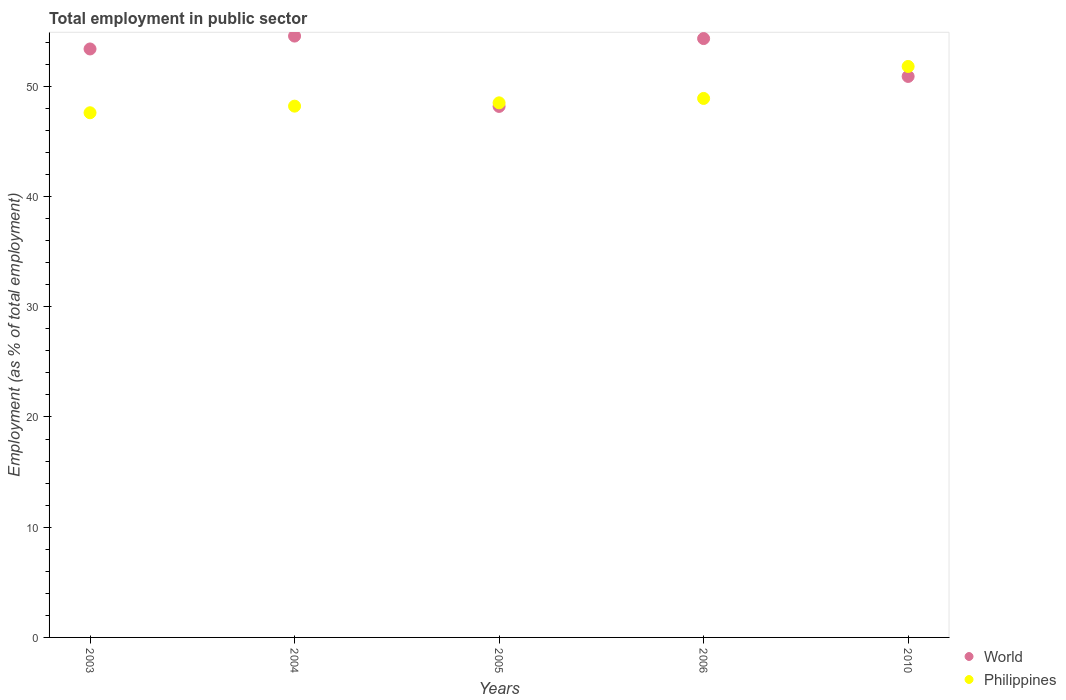Is the number of dotlines equal to the number of legend labels?
Your response must be concise. Yes. What is the employment in public sector in World in 2005?
Make the answer very short. 48.17. Across all years, what is the maximum employment in public sector in Philippines?
Offer a terse response. 51.8. Across all years, what is the minimum employment in public sector in World?
Keep it short and to the point. 48.17. In which year was the employment in public sector in World minimum?
Your answer should be compact. 2005. What is the total employment in public sector in Philippines in the graph?
Make the answer very short. 245. What is the difference between the employment in public sector in World in 2003 and that in 2010?
Provide a short and direct response. 2.49. What is the difference between the employment in public sector in Philippines in 2006 and the employment in public sector in World in 2003?
Ensure brevity in your answer.  -4.49. In the year 2006, what is the difference between the employment in public sector in Philippines and employment in public sector in World?
Keep it short and to the point. -5.43. In how many years, is the employment in public sector in World greater than 2 %?
Give a very brief answer. 5. What is the ratio of the employment in public sector in Philippines in 2005 to that in 2006?
Ensure brevity in your answer.  0.99. Is the difference between the employment in public sector in Philippines in 2004 and 2005 greater than the difference between the employment in public sector in World in 2004 and 2005?
Make the answer very short. No. What is the difference between the highest and the second highest employment in public sector in Philippines?
Your answer should be compact. 2.9. What is the difference between the highest and the lowest employment in public sector in Philippines?
Offer a terse response. 4.2. Is the sum of the employment in public sector in World in 2003 and 2006 greater than the maximum employment in public sector in Philippines across all years?
Your response must be concise. Yes. Is the employment in public sector in Philippines strictly greater than the employment in public sector in World over the years?
Keep it short and to the point. No. Is the employment in public sector in Philippines strictly less than the employment in public sector in World over the years?
Your response must be concise. No. What is the difference between two consecutive major ticks on the Y-axis?
Provide a succinct answer. 10. Are the values on the major ticks of Y-axis written in scientific E-notation?
Your answer should be compact. No. Does the graph contain any zero values?
Provide a succinct answer. No. How many legend labels are there?
Offer a terse response. 2. How are the legend labels stacked?
Keep it short and to the point. Vertical. What is the title of the graph?
Ensure brevity in your answer.  Total employment in public sector. Does "Turkmenistan" appear as one of the legend labels in the graph?
Your response must be concise. No. What is the label or title of the Y-axis?
Make the answer very short. Employment (as % of total employment). What is the Employment (as % of total employment) of World in 2003?
Give a very brief answer. 53.39. What is the Employment (as % of total employment) of Philippines in 2003?
Make the answer very short. 47.6. What is the Employment (as % of total employment) of World in 2004?
Make the answer very short. 54.56. What is the Employment (as % of total employment) in Philippines in 2004?
Give a very brief answer. 48.2. What is the Employment (as % of total employment) of World in 2005?
Your answer should be very brief. 48.17. What is the Employment (as % of total employment) of Philippines in 2005?
Provide a succinct answer. 48.5. What is the Employment (as % of total employment) of World in 2006?
Offer a terse response. 54.33. What is the Employment (as % of total employment) in Philippines in 2006?
Your response must be concise. 48.9. What is the Employment (as % of total employment) of World in 2010?
Your response must be concise. 50.9. What is the Employment (as % of total employment) in Philippines in 2010?
Provide a short and direct response. 51.8. Across all years, what is the maximum Employment (as % of total employment) in World?
Your response must be concise. 54.56. Across all years, what is the maximum Employment (as % of total employment) of Philippines?
Ensure brevity in your answer.  51.8. Across all years, what is the minimum Employment (as % of total employment) of World?
Keep it short and to the point. 48.17. Across all years, what is the minimum Employment (as % of total employment) in Philippines?
Offer a terse response. 47.6. What is the total Employment (as % of total employment) of World in the graph?
Ensure brevity in your answer.  261.35. What is the total Employment (as % of total employment) of Philippines in the graph?
Keep it short and to the point. 245. What is the difference between the Employment (as % of total employment) of World in 2003 and that in 2004?
Offer a very short reply. -1.17. What is the difference between the Employment (as % of total employment) of Philippines in 2003 and that in 2004?
Offer a terse response. -0.6. What is the difference between the Employment (as % of total employment) of World in 2003 and that in 2005?
Your answer should be very brief. 5.21. What is the difference between the Employment (as % of total employment) in Philippines in 2003 and that in 2005?
Ensure brevity in your answer.  -0.9. What is the difference between the Employment (as % of total employment) in World in 2003 and that in 2006?
Ensure brevity in your answer.  -0.94. What is the difference between the Employment (as % of total employment) of World in 2003 and that in 2010?
Offer a very short reply. 2.49. What is the difference between the Employment (as % of total employment) of Philippines in 2003 and that in 2010?
Make the answer very short. -4.2. What is the difference between the Employment (as % of total employment) in World in 2004 and that in 2005?
Give a very brief answer. 6.38. What is the difference between the Employment (as % of total employment) of Philippines in 2004 and that in 2005?
Provide a succinct answer. -0.3. What is the difference between the Employment (as % of total employment) of World in 2004 and that in 2006?
Provide a short and direct response. 0.23. What is the difference between the Employment (as % of total employment) of Philippines in 2004 and that in 2006?
Keep it short and to the point. -0.7. What is the difference between the Employment (as % of total employment) of World in 2004 and that in 2010?
Your answer should be compact. 3.66. What is the difference between the Employment (as % of total employment) in World in 2005 and that in 2006?
Offer a terse response. -6.16. What is the difference between the Employment (as % of total employment) of Philippines in 2005 and that in 2006?
Provide a succinct answer. -0.4. What is the difference between the Employment (as % of total employment) of World in 2005 and that in 2010?
Your answer should be very brief. -2.72. What is the difference between the Employment (as % of total employment) of Philippines in 2005 and that in 2010?
Provide a short and direct response. -3.3. What is the difference between the Employment (as % of total employment) of World in 2006 and that in 2010?
Your response must be concise. 3.44. What is the difference between the Employment (as % of total employment) of Philippines in 2006 and that in 2010?
Give a very brief answer. -2.9. What is the difference between the Employment (as % of total employment) of World in 2003 and the Employment (as % of total employment) of Philippines in 2004?
Keep it short and to the point. 5.19. What is the difference between the Employment (as % of total employment) of World in 2003 and the Employment (as % of total employment) of Philippines in 2005?
Your answer should be compact. 4.89. What is the difference between the Employment (as % of total employment) of World in 2003 and the Employment (as % of total employment) of Philippines in 2006?
Keep it short and to the point. 4.49. What is the difference between the Employment (as % of total employment) of World in 2003 and the Employment (as % of total employment) of Philippines in 2010?
Keep it short and to the point. 1.59. What is the difference between the Employment (as % of total employment) of World in 2004 and the Employment (as % of total employment) of Philippines in 2005?
Offer a very short reply. 6.06. What is the difference between the Employment (as % of total employment) of World in 2004 and the Employment (as % of total employment) of Philippines in 2006?
Make the answer very short. 5.66. What is the difference between the Employment (as % of total employment) in World in 2004 and the Employment (as % of total employment) in Philippines in 2010?
Give a very brief answer. 2.76. What is the difference between the Employment (as % of total employment) of World in 2005 and the Employment (as % of total employment) of Philippines in 2006?
Offer a very short reply. -0.73. What is the difference between the Employment (as % of total employment) in World in 2005 and the Employment (as % of total employment) in Philippines in 2010?
Ensure brevity in your answer.  -3.63. What is the difference between the Employment (as % of total employment) in World in 2006 and the Employment (as % of total employment) in Philippines in 2010?
Your answer should be compact. 2.53. What is the average Employment (as % of total employment) in World per year?
Offer a terse response. 52.27. In the year 2003, what is the difference between the Employment (as % of total employment) of World and Employment (as % of total employment) of Philippines?
Offer a terse response. 5.79. In the year 2004, what is the difference between the Employment (as % of total employment) of World and Employment (as % of total employment) of Philippines?
Give a very brief answer. 6.36. In the year 2005, what is the difference between the Employment (as % of total employment) in World and Employment (as % of total employment) in Philippines?
Your answer should be compact. -0.33. In the year 2006, what is the difference between the Employment (as % of total employment) of World and Employment (as % of total employment) of Philippines?
Keep it short and to the point. 5.43. In the year 2010, what is the difference between the Employment (as % of total employment) of World and Employment (as % of total employment) of Philippines?
Provide a short and direct response. -0.9. What is the ratio of the Employment (as % of total employment) in World in 2003 to that in 2004?
Make the answer very short. 0.98. What is the ratio of the Employment (as % of total employment) of Philippines in 2003 to that in 2004?
Keep it short and to the point. 0.99. What is the ratio of the Employment (as % of total employment) of World in 2003 to that in 2005?
Your response must be concise. 1.11. What is the ratio of the Employment (as % of total employment) of Philippines in 2003 to that in 2005?
Give a very brief answer. 0.98. What is the ratio of the Employment (as % of total employment) in World in 2003 to that in 2006?
Offer a very short reply. 0.98. What is the ratio of the Employment (as % of total employment) of Philippines in 2003 to that in 2006?
Provide a short and direct response. 0.97. What is the ratio of the Employment (as % of total employment) in World in 2003 to that in 2010?
Offer a terse response. 1.05. What is the ratio of the Employment (as % of total employment) in Philippines in 2003 to that in 2010?
Ensure brevity in your answer.  0.92. What is the ratio of the Employment (as % of total employment) of World in 2004 to that in 2005?
Make the answer very short. 1.13. What is the ratio of the Employment (as % of total employment) in Philippines in 2004 to that in 2005?
Your response must be concise. 0.99. What is the ratio of the Employment (as % of total employment) in Philippines in 2004 to that in 2006?
Your answer should be compact. 0.99. What is the ratio of the Employment (as % of total employment) of World in 2004 to that in 2010?
Provide a short and direct response. 1.07. What is the ratio of the Employment (as % of total employment) of Philippines in 2004 to that in 2010?
Make the answer very short. 0.93. What is the ratio of the Employment (as % of total employment) in World in 2005 to that in 2006?
Provide a short and direct response. 0.89. What is the ratio of the Employment (as % of total employment) of World in 2005 to that in 2010?
Offer a very short reply. 0.95. What is the ratio of the Employment (as % of total employment) of Philippines in 2005 to that in 2010?
Your response must be concise. 0.94. What is the ratio of the Employment (as % of total employment) of World in 2006 to that in 2010?
Provide a succinct answer. 1.07. What is the ratio of the Employment (as % of total employment) in Philippines in 2006 to that in 2010?
Give a very brief answer. 0.94. What is the difference between the highest and the second highest Employment (as % of total employment) in World?
Provide a succinct answer. 0.23. What is the difference between the highest and the lowest Employment (as % of total employment) in World?
Your answer should be very brief. 6.38. What is the difference between the highest and the lowest Employment (as % of total employment) in Philippines?
Ensure brevity in your answer.  4.2. 